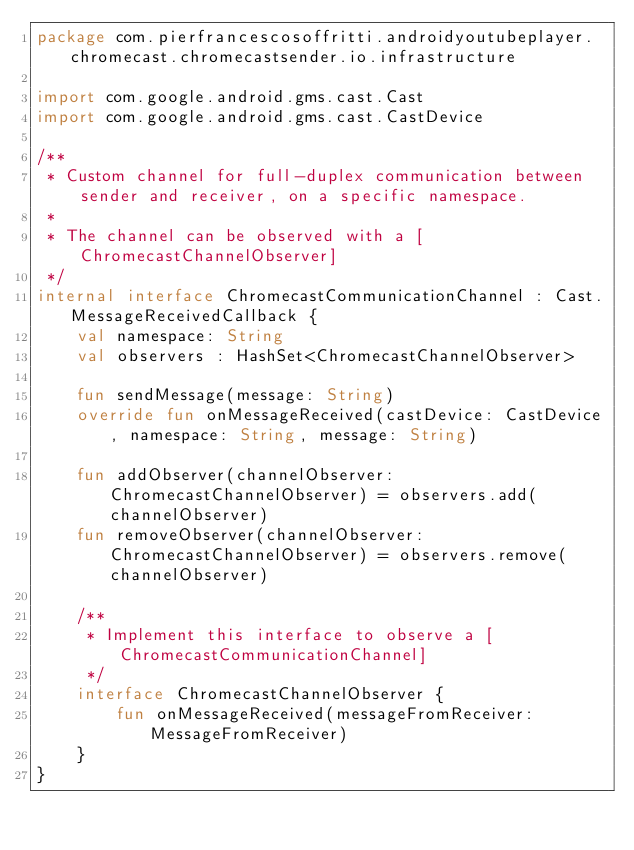<code> <loc_0><loc_0><loc_500><loc_500><_Kotlin_>package com.pierfrancescosoffritti.androidyoutubeplayer.chromecast.chromecastsender.io.infrastructure

import com.google.android.gms.cast.Cast
import com.google.android.gms.cast.CastDevice

/**
 * Custom channel for full-duplex communication between sender and receiver, on a specific namespace.
 *
 * The channel can be observed with a [ChromecastChannelObserver]
 */
internal interface ChromecastCommunicationChannel : Cast.MessageReceivedCallback {
    val namespace: String
    val observers : HashSet<ChromecastChannelObserver>

    fun sendMessage(message: String)
    override fun onMessageReceived(castDevice: CastDevice, namespace: String, message: String)

    fun addObserver(channelObserver: ChromecastChannelObserver) = observers.add(channelObserver)
    fun removeObserver(channelObserver: ChromecastChannelObserver) = observers.remove(channelObserver)

    /**
     * Implement this interface to observe a [ChromecastCommunicationChannel]
     */
    interface ChromecastChannelObserver {
        fun onMessageReceived(messageFromReceiver: MessageFromReceiver)
    }
}</code> 